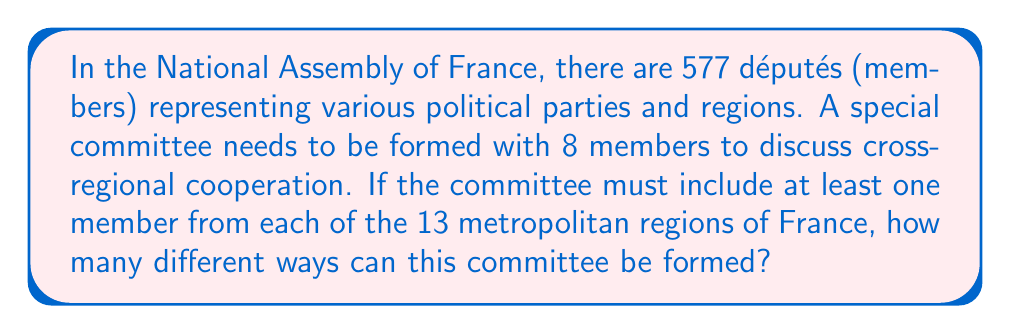Can you solve this math problem? Let's approach this step-by-step:

1) First, we need to ensure that each of the 13 regions is represented. This means we must select one député from each region:

   $13$ positions are filled, leaving $8 - 13 = -5$ positions

2) However, we can't have a negative number of positions. This means we need to select more than one député from some regions to reach a total of 8 members.

3) This problem can be reformulated as: In how many ways can we distribute 5 additional positions among 13 regions?

4) This is equivalent to the problem of distributing 5 identical objects into 13 distinct boxes, which is a classic stars and bars problem in combinatorics.

5) The formula for this is:

   $$\binom{n+k-1}{k} = \binom{13+5-1}{5} = \binom{17}{5}$$

   Where $n = 13$ (number of regions) and $k = 5$ (additional positions)

6) We can calculate this:

   $$\binom{17}{5} = \frac{17!}{5!(17-5)!} = \frac{17!}{5!12!} = 6188$$

7) This gives us the number of ways to distribute the additional 5 positions. However, for each of these distributions, we still need to choose which specific députés will fill these positions.

8) The total number of ways to form the committee will be this number multiplied by the number of ways to choose one député from each region, and then multiplied by the number of ways to choose the additional députés for the regions that get more than one representative.

9) However, calculating this exact number would require knowing the number of députés in each region, which isn't provided in the problem statement.

Therefore, 6188 represents the number of different possible structures for the committee in terms of regional representation, but the total number of possible committees would be much larger.
Answer: 6188 different regional distributions 